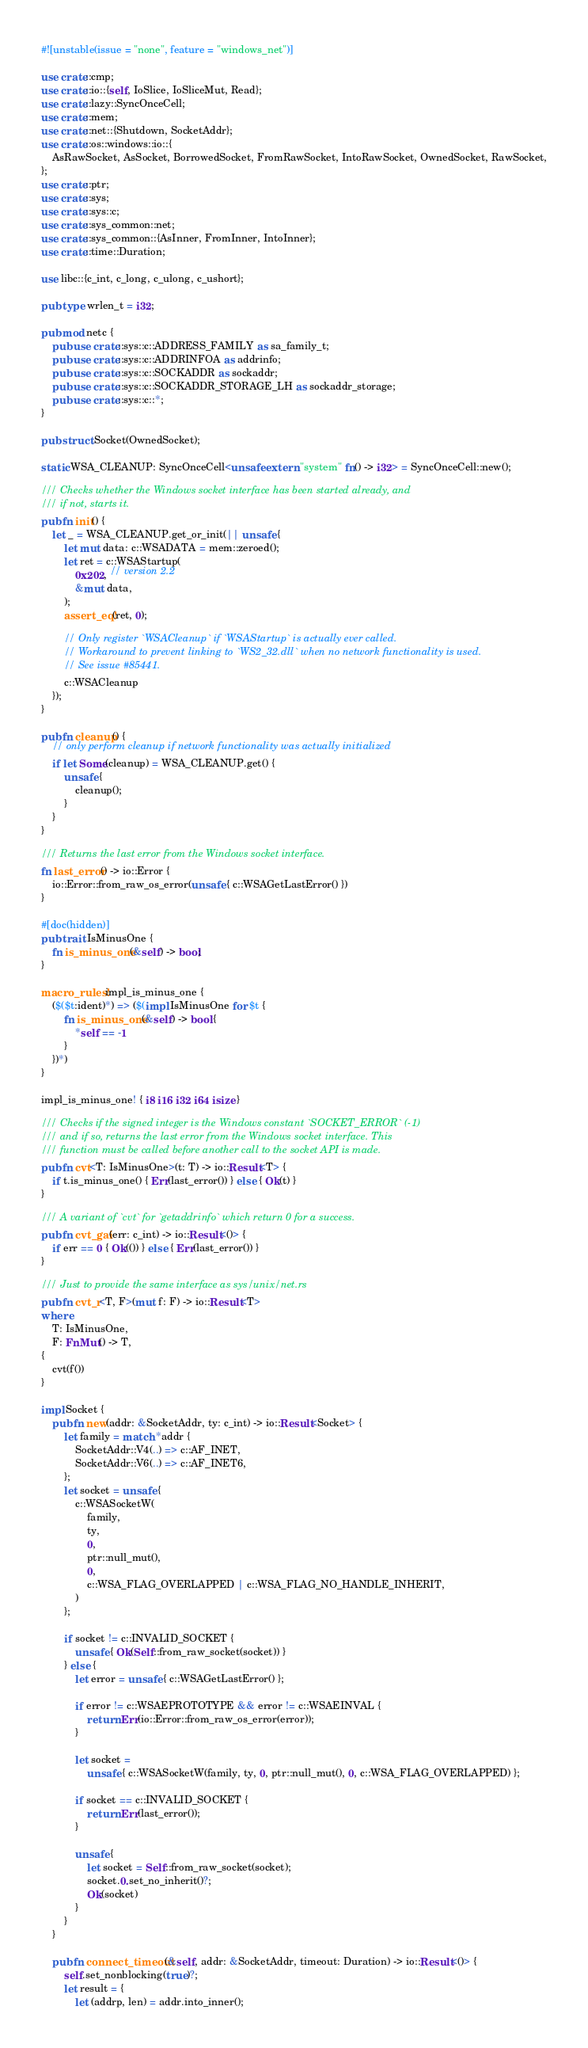Convert code to text. <code><loc_0><loc_0><loc_500><loc_500><_Rust_>#![unstable(issue = "none", feature = "windows_net")]

use crate::cmp;
use crate::io::{self, IoSlice, IoSliceMut, Read};
use crate::lazy::SyncOnceCell;
use crate::mem;
use crate::net::{Shutdown, SocketAddr};
use crate::os::windows::io::{
    AsRawSocket, AsSocket, BorrowedSocket, FromRawSocket, IntoRawSocket, OwnedSocket, RawSocket,
};
use crate::ptr;
use crate::sys;
use crate::sys::c;
use crate::sys_common::net;
use crate::sys_common::{AsInner, FromInner, IntoInner};
use crate::time::Duration;

use libc::{c_int, c_long, c_ulong, c_ushort};

pub type wrlen_t = i32;

pub mod netc {
    pub use crate::sys::c::ADDRESS_FAMILY as sa_family_t;
    pub use crate::sys::c::ADDRINFOA as addrinfo;
    pub use crate::sys::c::SOCKADDR as sockaddr;
    pub use crate::sys::c::SOCKADDR_STORAGE_LH as sockaddr_storage;
    pub use crate::sys::c::*;
}

pub struct Socket(OwnedSocket);

static WSA_CLEANUP: SyncOnceCell<unsafe extern "system" fn() -> i32> = SyncOnceCell::new();

/// Checks whether the Windows socket interface has been started already, and
/// if not, starts it.
pub fn init() {
    let _ = WSA_CLEANUP.get_or_init(|| unsafe {
        let mut data: c::WSADATA = mem::zeroed();
        let ret = c::WSAStartup(
            0x202, // version 2.2
            &mut data,
        );
        assert_eq!(ret, 0);

        // Only register `WSACleanup` if `WSAStartup` is actually ever called.
        // Workaround to prevent linking to `WS2_32.dll` when no network functionality is used.
        // See issue #85441.
        c::WSACleanup
    });
}

pub fn cleanup() {
    // only perform cleanup if network functionality was actually initialized
    if let Some(cleanup) = WSA_CLEANUP.get() {
        unsafe {
            cleanup();
        }
    }
}

/// Returns the last error from the Windows socket interface.
fn last_error() -> io::Error {
    io::Error::from_raw_os_error(unsafe { c::WSAGetLastError() })
}

#[doc(hidden)]
pub trait IsMinusOne {
    fn is_minus_one(&self) -> bool;
}

macro_rules! impl_is_minus_one {
    ($($t:ident)*) => ($(impl IsMinusOne for $t {
        fn is_minus_one(&self) -> bool {
            *self == -1
        }
    })*)
}

impl_is_minus_one! { i8 i16 i32 i64 isize }

/// Checks if the signed integer is the Windows constant `SOCKET_ERROR` (-1)
/// and if so, returns the last error from the Windows socket interface. This
/// function must be called before another call to the socket API is made.
pub fn cvt<T: IsMinusOne>(t: T) -> io::Result<T> {
    if t.is_minus_one() { Err(last_error()) } else { Ok(t) }
}

/// A variant of `cvt` for `getaddrinfo` which return 0 for a success.
pub fn cvt_gai(err: c_int) -> io::Result<()> {
    if err == 0 { Ok(()) } else { Err(last_error()) }
}

/// Just to provide the same interface as sys/unix/net.rs
pub fn cvt_r<T, F>(mut f: F) -> io::Result<T>
where
    T: IsMinusOne,
    F: FnMut() -> T,
{
    cvt(f())
}

impl Socket {
    pub fn new(addr: &SocketAddr, ty: c_int) -> io::Result<Socket> {
        let family = match *addr {
            SocketAddr::V4(..) => c::AF_INET,
            SocketAddr::V6(..) => c::AF_INET6,
        };
        let socket = unsafe {
            c::WSASocketW(
                family,
                ty,
                0,
                ptr::null_mut(),
                0,
                c::WSA_FLAG_OVERLAPPED | c::WSA_FLAG_NO_HANDLE_INHERIT,
            )
        };

        if socket != c::INVALID_SOCKET {
            unsafe { Ok(Self::from_raw_socket(socket)) }
        } else {
            let error = unsafe { c::WSAGetLastError() };

            if error != c::WSAEPROTOTYPE && error != c::WSAEINVAL {
                return Err(io::Error::from_raw_os_error(error));
            }

            let socket =
                unsafe { c::WSASocketW(family, ty, 0, ptr::null_mut(), 0, c::WSA_FLAG_OVERLAPPED) };

            if socket == c::INVALID_SOCKET {
                return Err(last_error());
            }

            unsafe {
                let socket = Self::from_raw_socket(socket);
                socket.0.set_no_inherit()?;
                Ok(socket)
            }
        }
    }

    pub fn connect_timeout(&self, addr: &SocketAddr, timeout: Duration) -> io::Result<()> {
        self.set_nonblocking(true)?;
        let result = {
            let (addrp, len) = addr.into_inner();</code> 